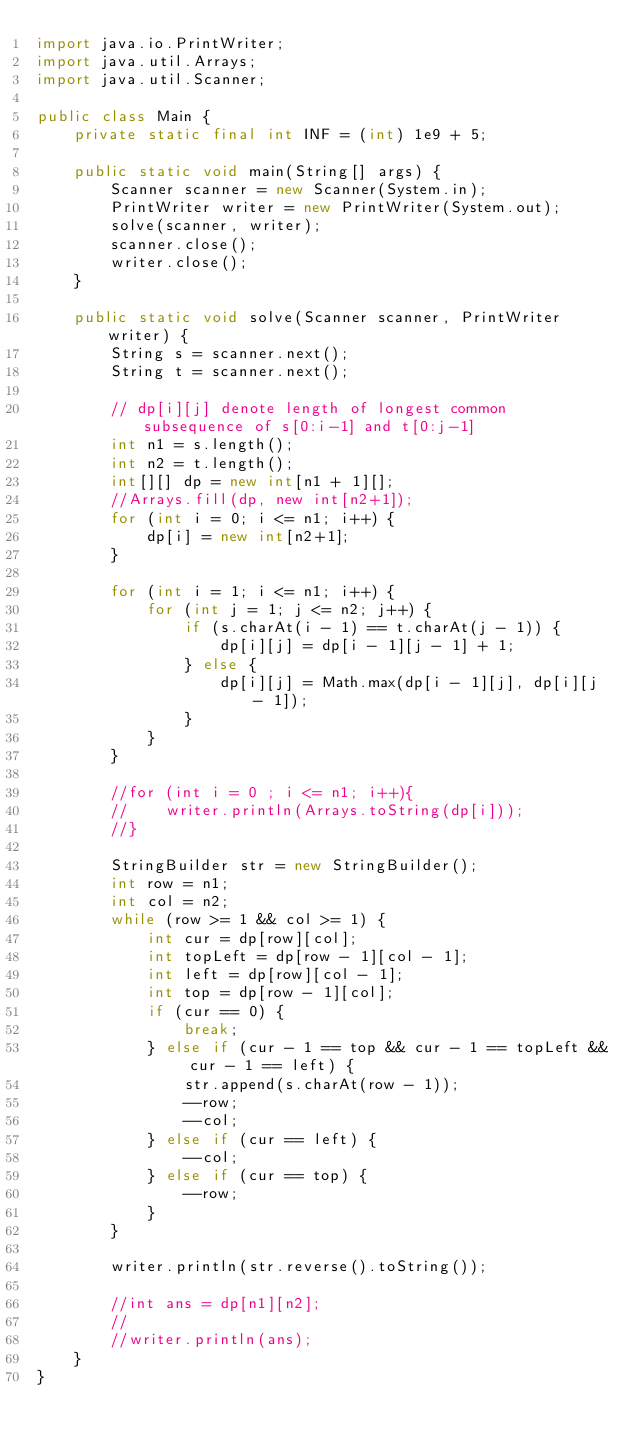<code> <loc_0><loc_0><loc_500><loc_500><_Java_>import java.io.PrintWriter;
import java.util.Arrays;
import java.util.Scanner;

public class Main {
    private static final int INF = (int) 1e9 + 5;

    public static void main(String[] args) {
        Scanner scanner = new Scanner(System.in);
        PrintWriter writer = new PrintWriter(System.out);
        solve(scanner, writer);
        scanner.close();
        writer.close();
    }

    public static void solve(Scanner scanner, PrintWriter writer) {
        String s = scanner.next();
        String t = scanner.next();

        // dp[i][j] denote length of longest common subsequence of s[0:i-1] and t[0:j-1]
        int n1 = s.length();
        int n2 = t.length();
        int[][] dp = new int[n1 + 1][];
        //Arrays.fill(dp, new int[n2+1]);
        for (int i = 0; i <= n1; i++) {
            dp[i] = new int[n2+1];
        }

        for (int i = 1; i <= n1; i++) {
            for (int j = 1; j <= n2; j++) {
                if (s.charAt(i - 1) == t.charAt(j - 1)) {
                    dp[i][j] = dp[i - 1][j - 1] + 1;
                } else {
                    dp[i][j] = Math.max(dp[i - 1][j], dp[i][j - 1]);
                }
            }
        }

        //for (int i = 0 ; i <= n1; i++){
        //    writer.println(Arrays.toString(dp[i]));
        //}

        StringBuilder str = new StringBuilder();
        int row = n1;
        int col = n2;
        while (row >= 1 && col >= 1) {
            int cur = dp[row][col];
            int topLeft = dp[row - 1][col - 1];
            int left = dp[row][col - 1];
            int top = dp[row - 1][col];
            if (cur == 0) {
                break;
            } else if (cur - 1 == top && cur - 1 == topLeft && cur - 1 == left) {
                str.append(s.charAt(row - 1));
                --row;
                --col;
            } else if (cur == left) {
                --col;
            } else if (cur == top) {
                --row;
            }
        }

        writer.println(str.reverse().toString());

        //int ans = dp[n1][n2];
        //
        //writer.println(ans);
    }
}
</code> 